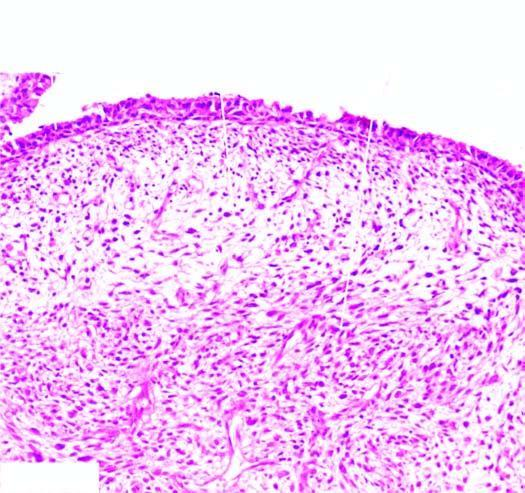what does the tumour show?
Answer the question using a single word or phrase. Characteristic submucosal cambium layer of tumour cells 